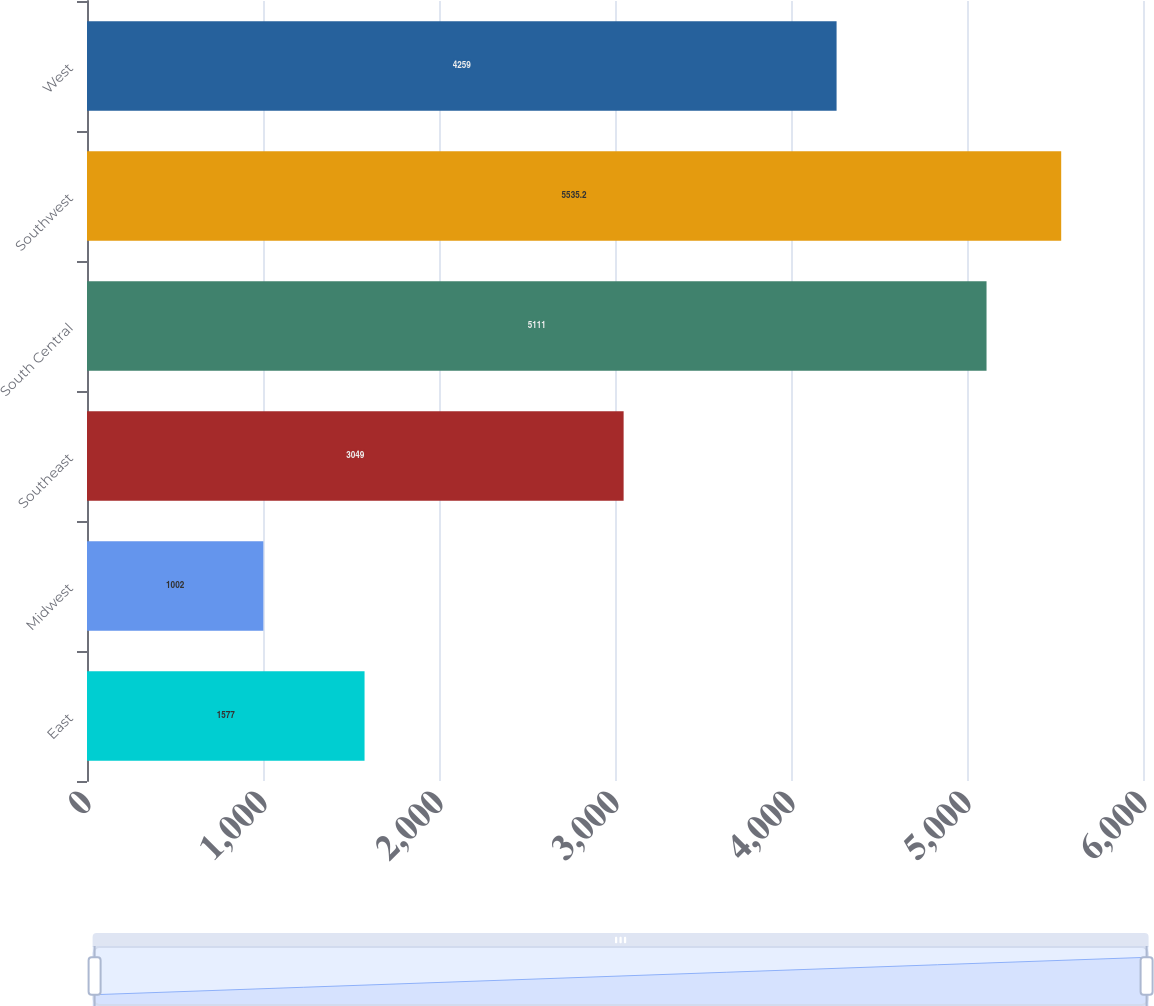Convert chart to OTSL. <chart><loc_0><loc_0><loc_500><loc_500><bar_chart><fcel>East<fcel>Midwest<fcel>Southeast<fcel>South Central<fcel>Southwest<fcel>West<nl><fcel>1577<fcel>1002<fcel>3049<fcel>5111<fcel>5535.2<fcel>4259<nl></chart> 